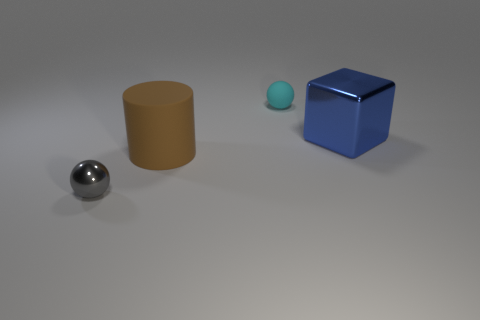Add 3 tiny purple rubber objects. How many objects exist? 7 Subtract all blocks. How many objects are left? 3 Subtract 0 red spheres. How many objects are left? 4 Subtract all purple spheres. Subtract all small matte spheres. How many objects are left? 3 Add 3 brown matte objects. How many brown matte objects are left? 4 Add 1 large matte things. How many large matte things exist? 2 